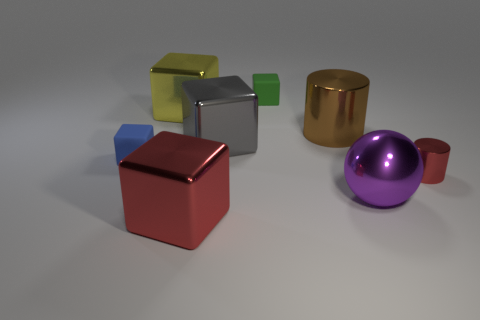Subtract all red blocks. How many blocks are left? 4 Subtract all brown cubes. Subtract all red spheres. How many cubes are left? 5 Add 1 red cylinders. How many objects exist? 9 Subtract all spheres. How many objects are left? 7 Add 3 metallic balls. How many metallic balls exist? 4 Subtract 0 blue cylinders. How many objects are left? 8 Subtract all purple spheres. Subtract all yellow metal blocks. How many objects are left? 6 Add 4 big purple balls. How many big purple balls are left? 5 